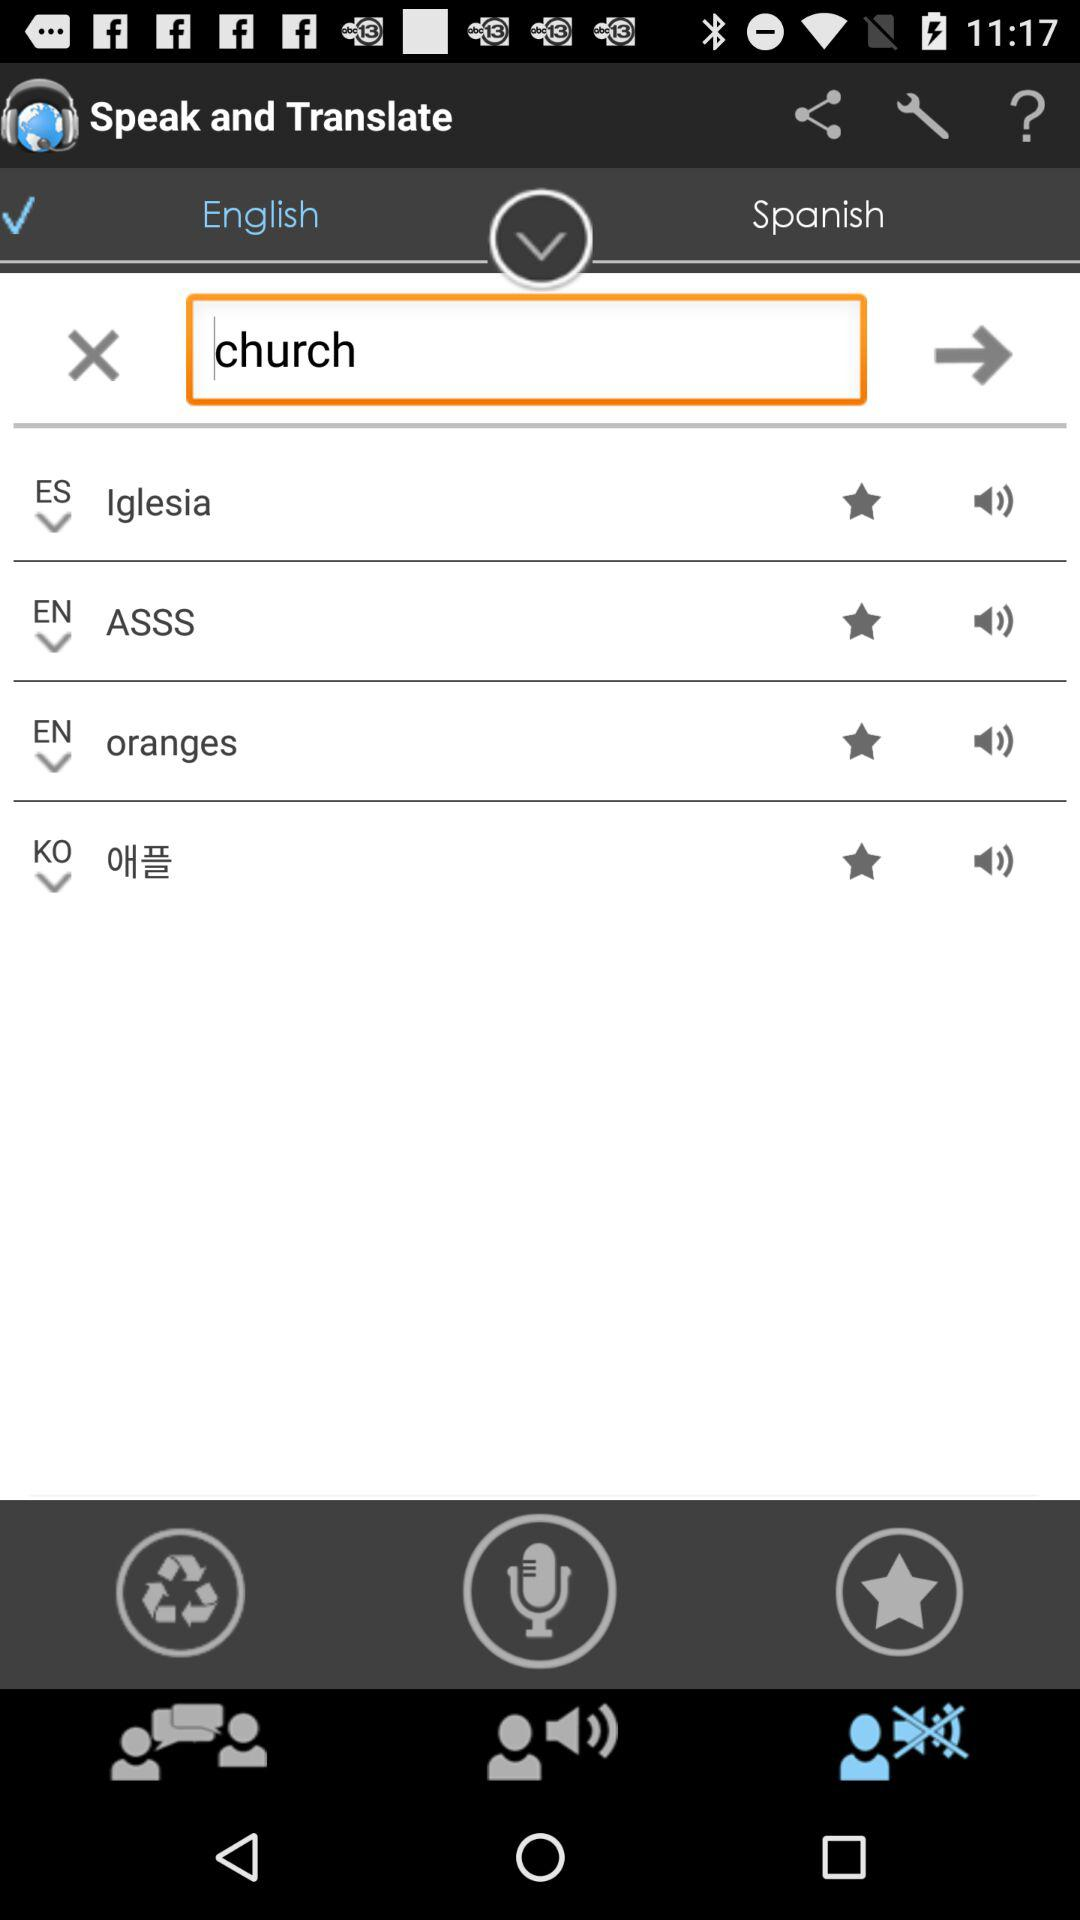Which text is entered in the input field to translate? The entered text is "church". 